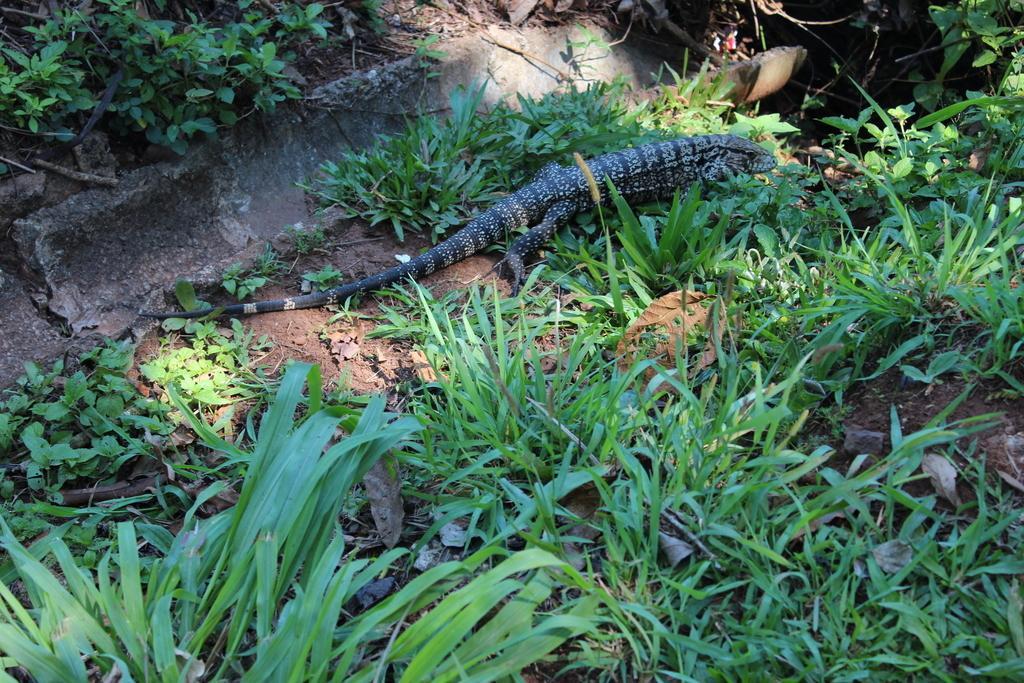Describe this image in one or two sentences. In this image we can see a reptile on the ground and there are some small plants and grass on the ground. 